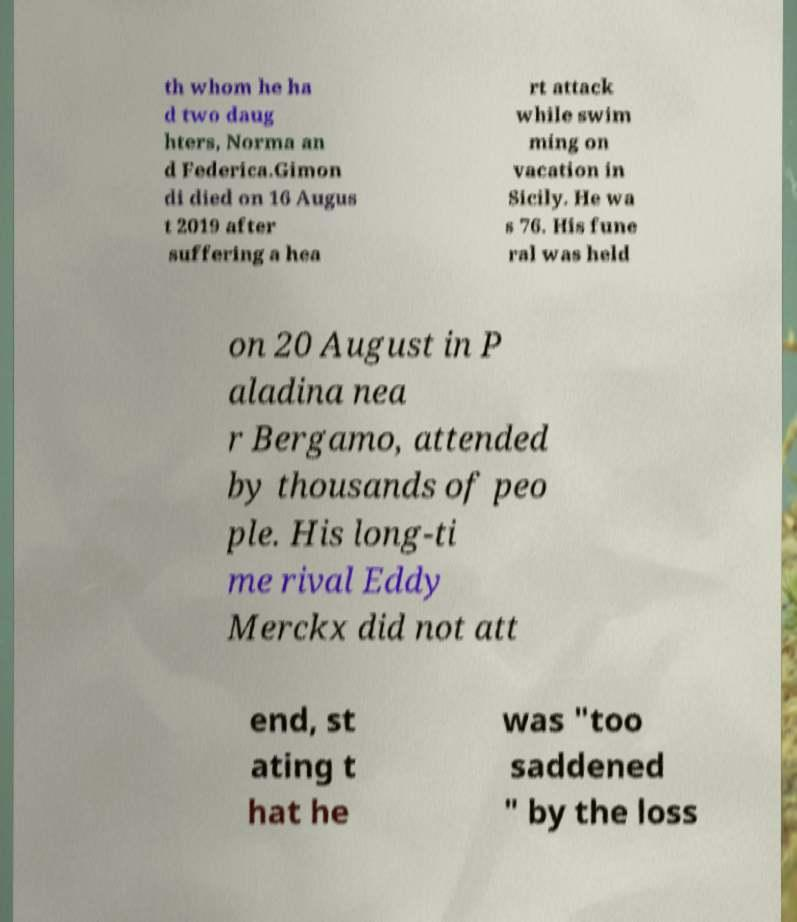Could you assist in decoding the text presented in this image and type it out clearly? th whom he ha d two daug hters, Norma an d Federica.Gimon di died on 16 Augus t 2019 after suffering a hea rt attack while swim ming on vacation in Sicily. He wa s 76. His fune ral was held on 20 August in P aladina nea r Bergamo, attended by thousands of peo ple. His long-ti me rival Eddy Merckx did not att end, st ating t hat he was "too saddened " by the loss 